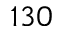Convert formula to latex. <formula><loc_0><loc_0><loc_500><loc_500>1 3 0</formula> 